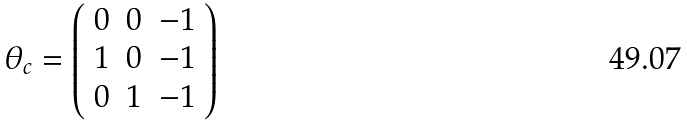Convert formula to latex. <formula><loc_0><loc_0><loc_500><loc_500>\theta _ { c } = \left ( \begin{array} { c c c } 0 & 0 & - 1 \\ 1 & 0 & - 1 \\ 0 & 1 & - 1 \end{array} \right )</formula> 